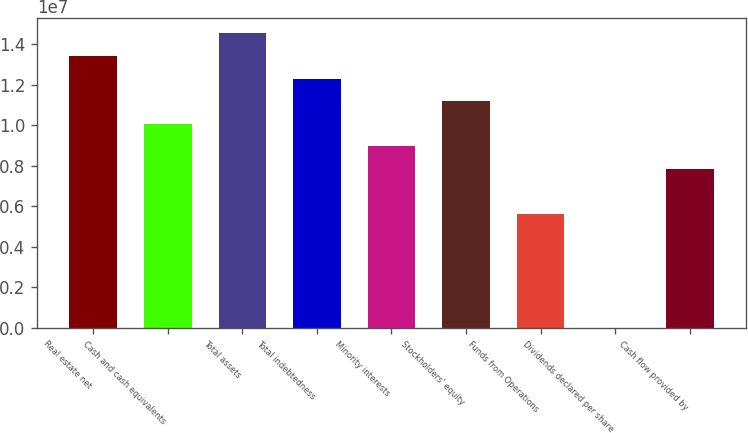Convert chart to OTSL. <chart><loc_0><loc_0><loc_500><loc_500><bar_chart><fcel>Real estate net<fcel>Cash and cash equivalents<fcel>Total assets<fcel>Total indebtedness<fcel>Minority interests<fcel>Stockholders' equity<fcel>Funds from Operations<fcel>Dividends declared per share<fcel>Cash flow provided by<nl><fcel>1.34312e+07<fcel>1.00734e+07<fcel>1.45504e+07<fcel>1.23119e+07<fcel>8.95411e+06<fcel>1.11926e+07<fcel>5.59632e+06<fcel>8.7<fcel>7.83485e+06<nl></chart> 